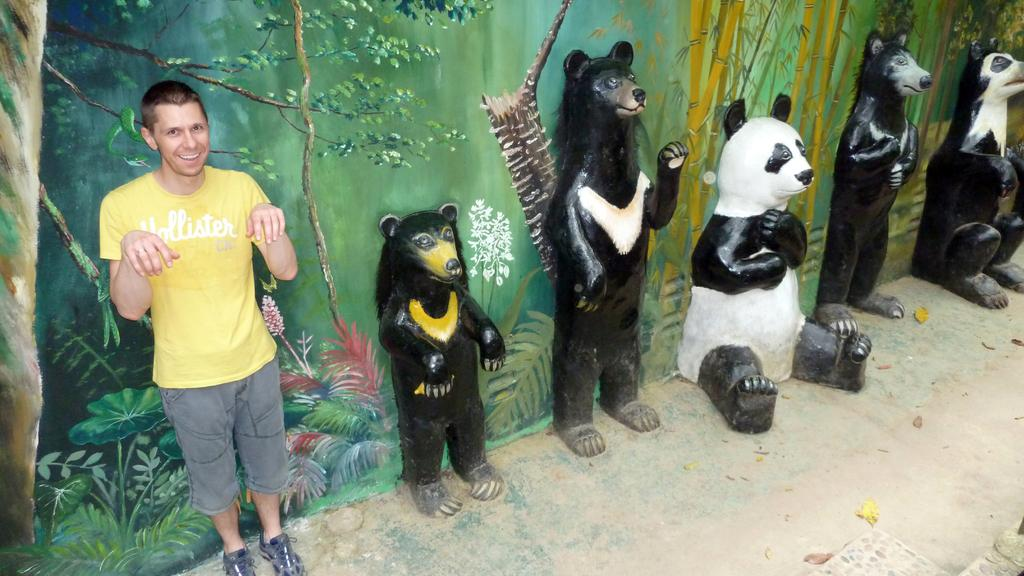What type of objects are depicted as sculptures in the image? There are sculptures of animals in the image. What is the subject matter of the painting on the wall in the image? The painting on the wall in the image features trees and plants. Can you describe the person in the image? A person is standing in the image. How does the person in the image distribute their sleep schedule? There is no information about the person's sleep schedule in the image. Is the person in the image swimming? No, the person in the image is not swimming; they are standing. 